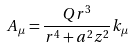<formula> <loc_0><loc_0><loc_500><loc_500>A _ { \mu } = \frac { Q r ^ { 3 } } { r ^ { 4 } + a ^ { 2 } z ^ { 2 } } k _ { \mu }</formula> 